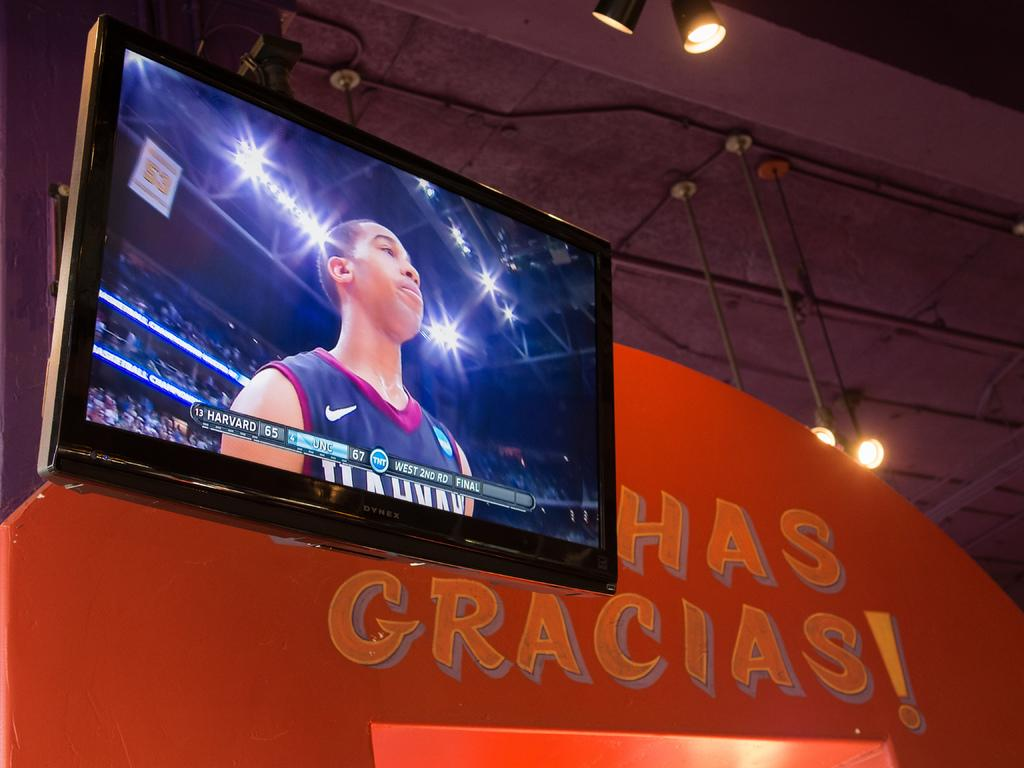<image>
Describe the image concisely. A TV showing a sports player hands in front of a sign with Muchas Gracias written on it. 